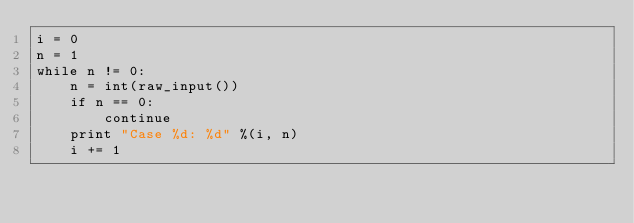<code> <loc_0><loc_0><loc_500><loc_500><_Python_>i = 0
n = 1
while n != 0:
	n = int(raw_input())
	if n == 0:
		continue
	print "Case %d: %d" %(i, n)
	i += 1</code> 